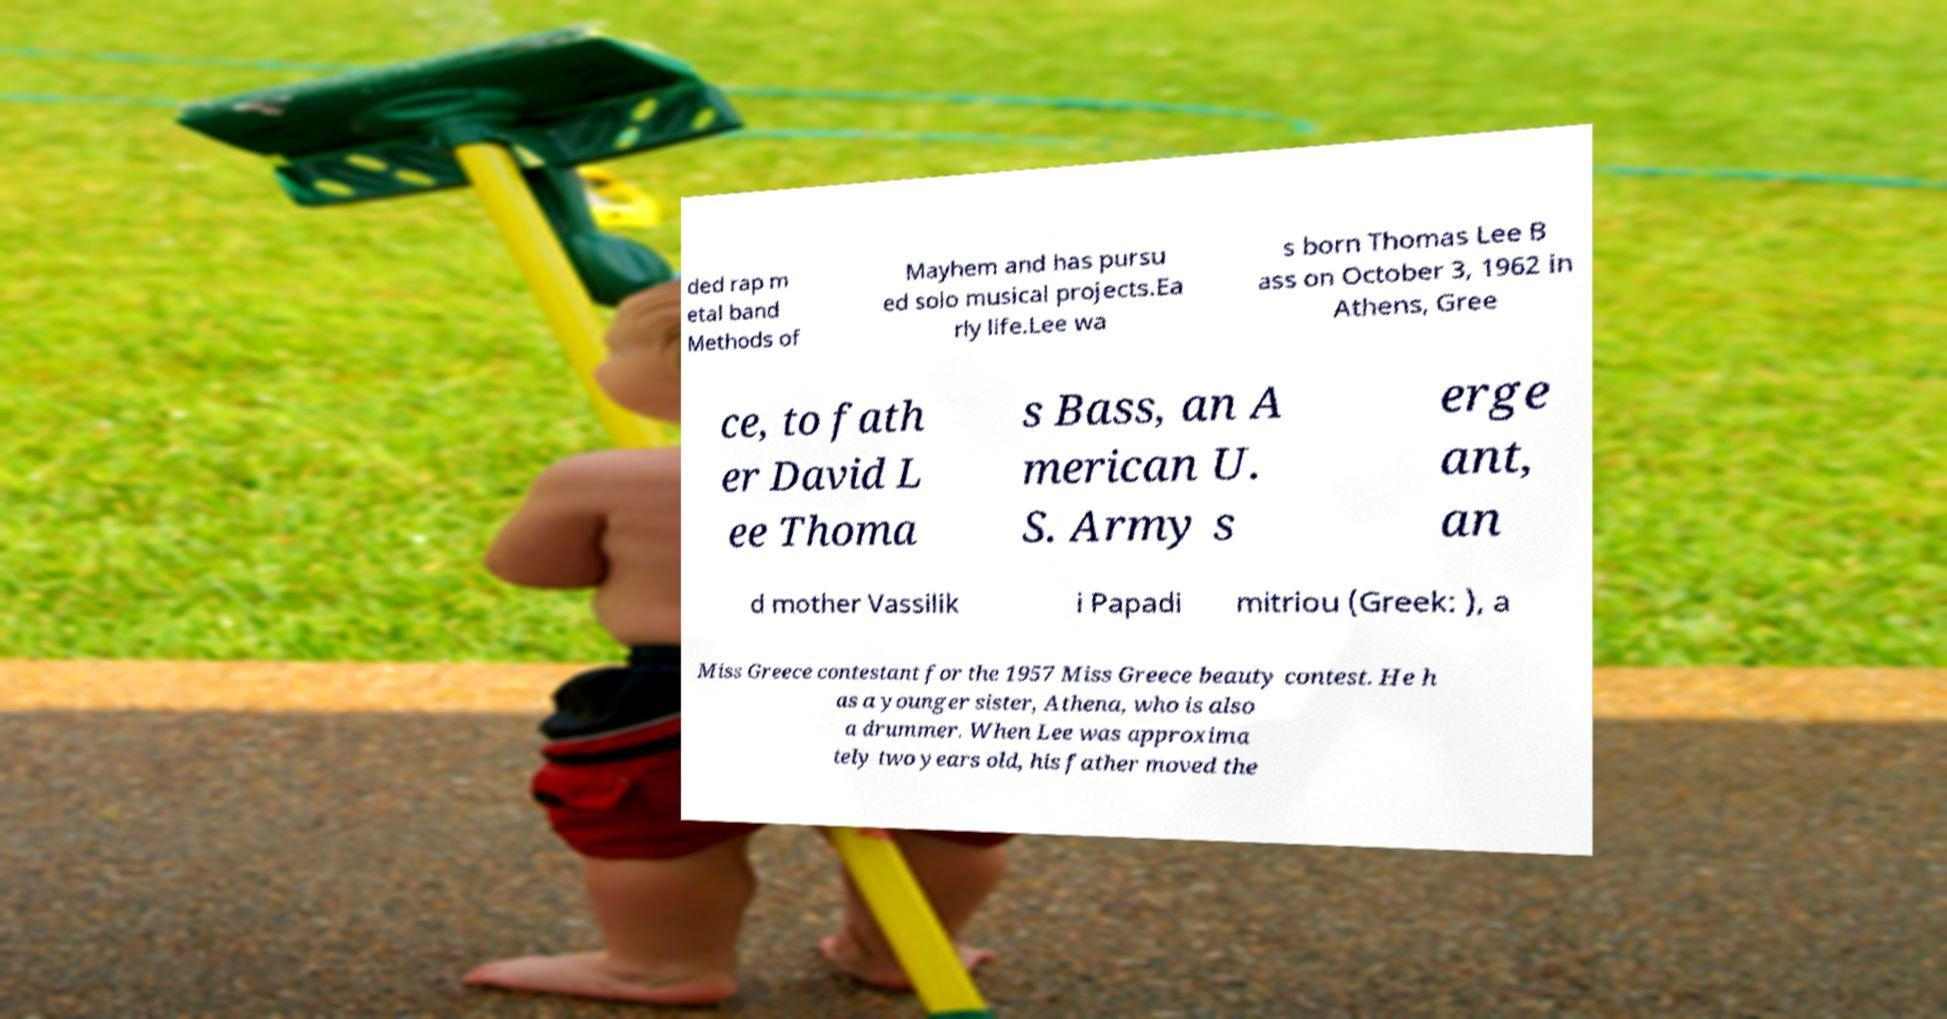For documentation purposes, I need the text within this image transcribed. Could you provide that? ded rap m etal band Methods of Mayhem and has pursu ed solo musical projects.Ea rly life.Lee wa s born Thomas Lee B ass on October 3, 1962 in Athens, Gree ce, to fath er David L ee Thoma s Bass, an A merican U. S. Army s erge ant, an d mother Vassilik i Papadi mitriou (Greek: ), a Miss Greece contestant for the 1957 Miss Greece beauty contest. He h as a younger sister, Athena, who is also a drummer. When Lee was approxima tely two years old, his father moved the 